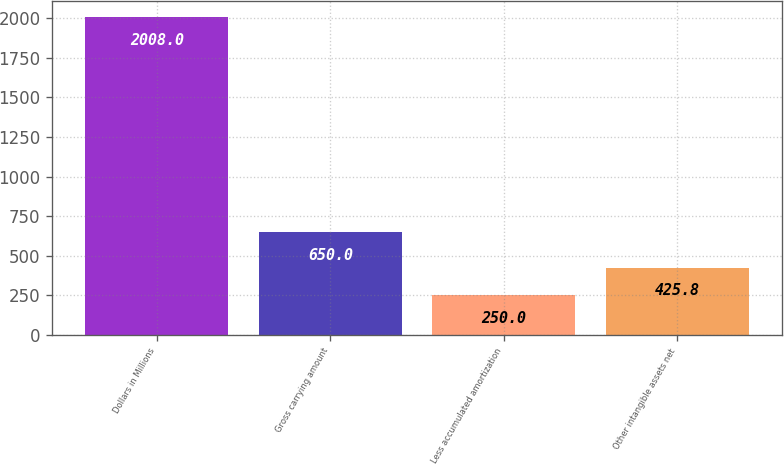Convert chart. <chart><loc_0><loc_0><loc_500><loc_500><bar_chart><fcel>Dollars in Millions<fcel>Gross carrying amount<fcel>Less accumulated amortization<fcel>Other intangible assets net<nl><fcel>2008<fcel>650<fcel>250<fcel>425.8<nl></chart> 